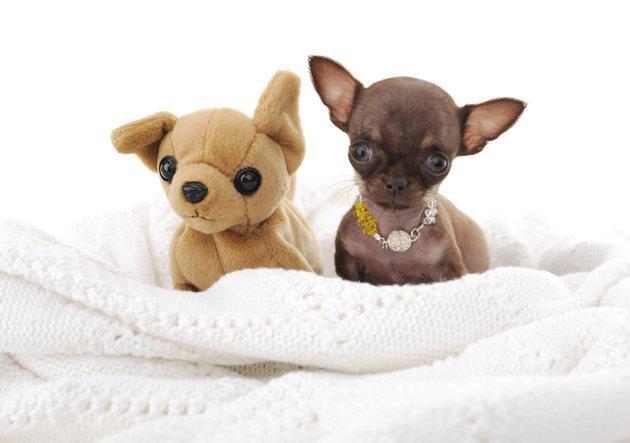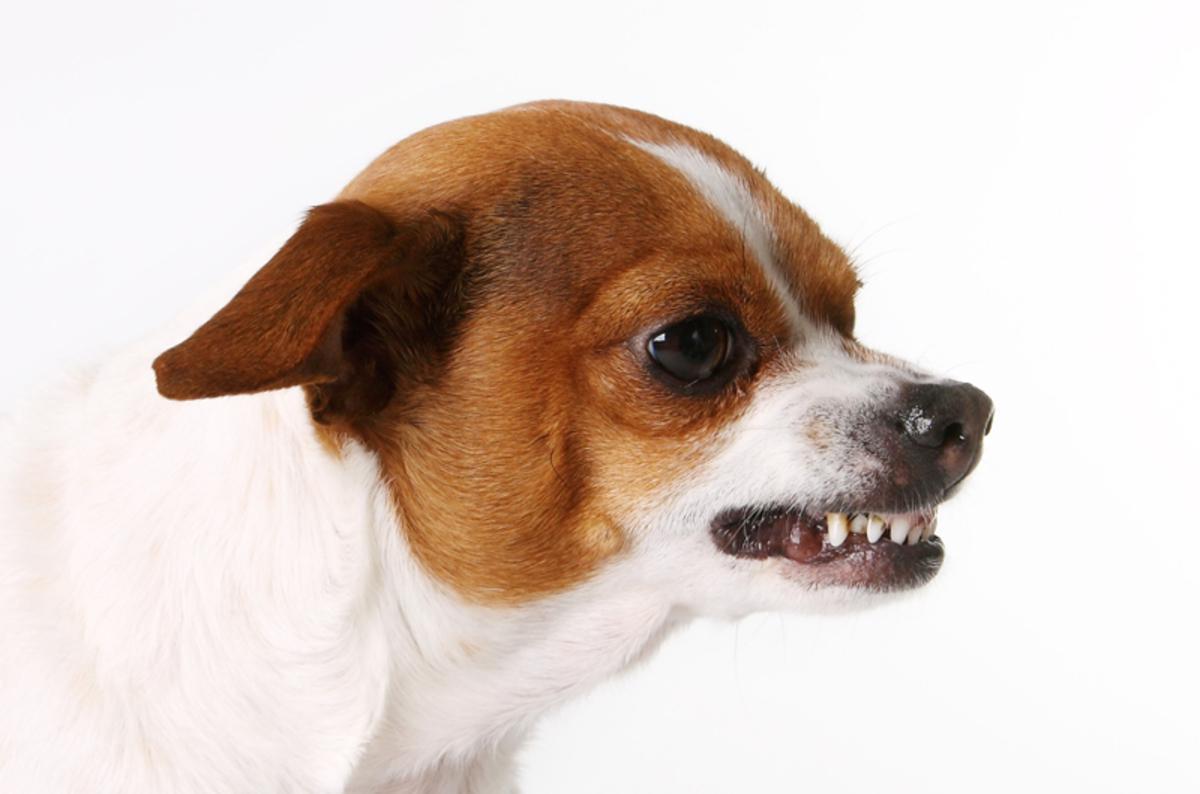The first image is the image on the left, the second image is the image on the right. For the images shown, is this caption "Each image shows a chihuahua dog wearing a sombrero on top of its head." true? Answer yes or no. No. The first image is the image on the left, the second image is the image on the right. For the images shown, is this caption "There are two chihuahuas wearing sombreros on top of their heads." true? Answer yes or no. No. 